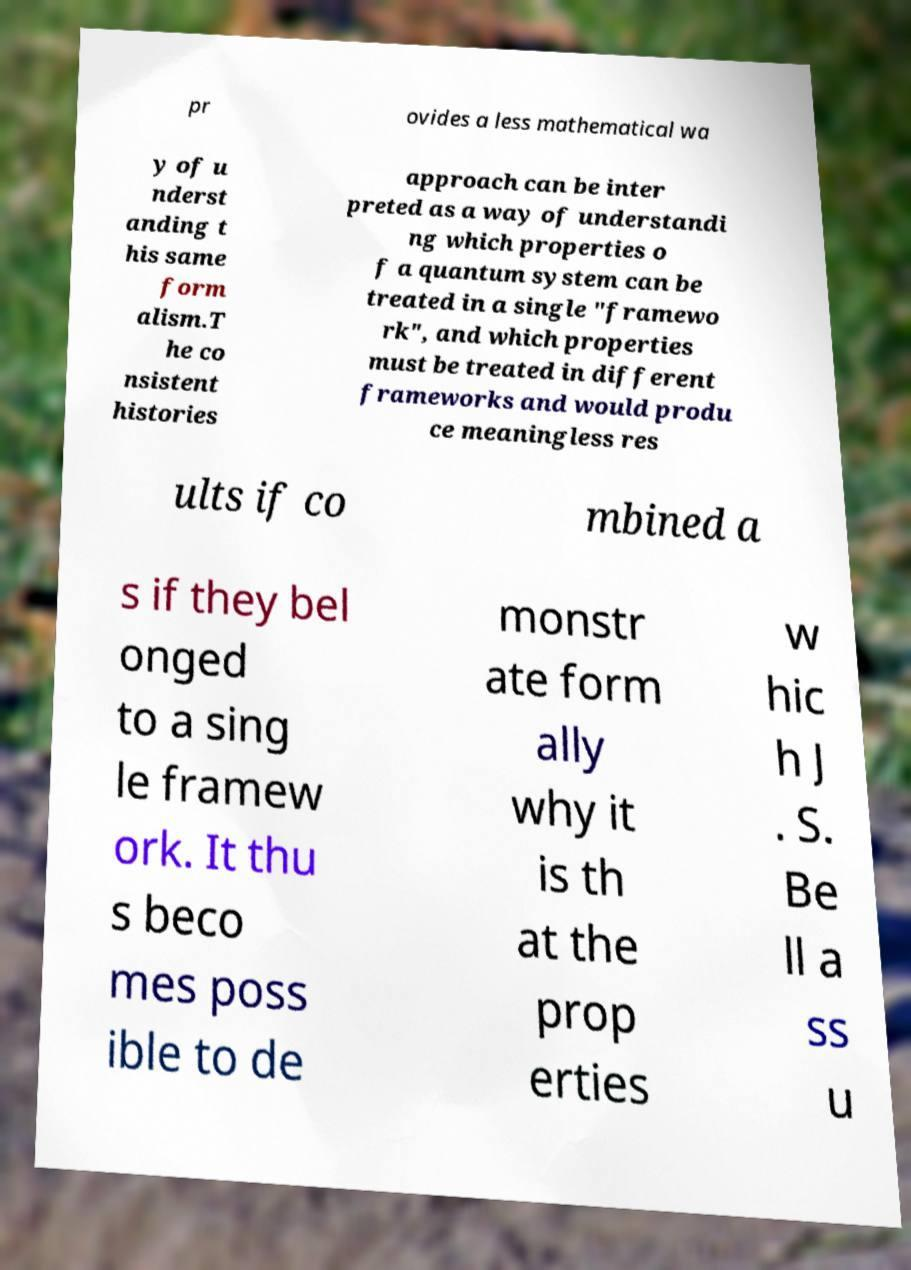For documentation purposes, I need the text within this image transcribed. Could you provide that? pr ovides a less mathematical wa y of u nderst anding t his same form alism.T he co nsistent histories approach can be inter preted as a way of understandi ng which properties o f a quantum system can be treated in a single "framewo rk", and which properties must be treated in different frameworks and would produ ce meaningless res ults if co mbined a s if they bel onged to a sing le framew ork. It thu s beco mes poss ible to de monstr ate form ally why it is th at the prop erties w hic h J . S. Be ll a ss u 